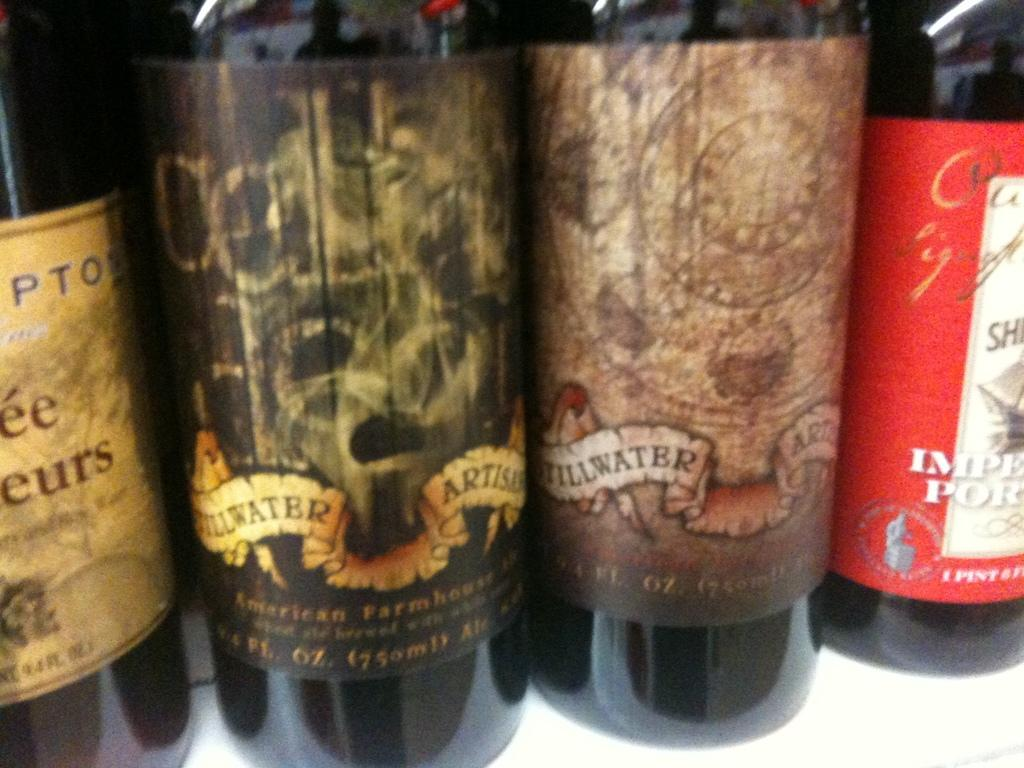<image>
Create a compact narrative representing the image presented. Several Stillwater brand wine bottles line up on a table. 